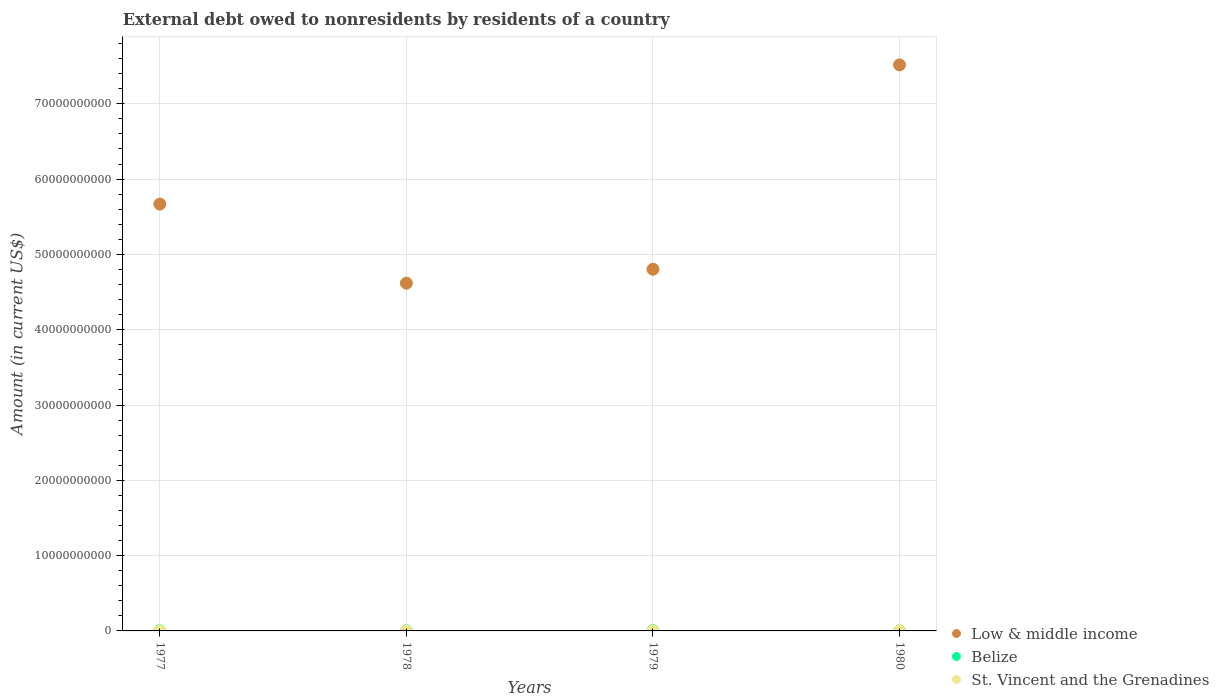Is the number of dotlines equal to the number of legend labels?
Give a very brief answer. No. What is the external debt owed by residents in Belize in 1977?
Provide a short and direct response. 1.13e+07. Across all years, what is the maximum external debt owed by residents in Belize?
Keep it short and to the point. 3.81e+07. Across all years, what is the minimum external debt owed by residents in Low & middle income?
Offer a terse response. 4.62e+1. What is the total external debt owed by residents in Belize in the graph?
Your response must be concise. 6.21e+07. What is the difference between the external debt owed by residents in Low & middle income in 1977 and that in 1978?
Your response must be concise. 1.05e+1. What is the difference between the external debt owed by residents in Belize in 1980 and the external debt owed by residents in Low & middle income in 1977?
Keep it short and to the point. -5.67e+1. What is the average external debt owed by residents in St. Vincent and the Grenadines per year?
Your response must be concise. 1.63e+06. In the year 1979, what is the difference between the external debt owed by residents in St. Vincent and the Grenadines and external debt owed by residents in Belize?
Offer a very short reply. -3.68e+07. What is the ratio of the external debt owed by residents in Low & middle income in 1977 to that in 1979?
Your answer should be very brief. 1.18. Is the external debt owed by residents in Low & middle income in 1977 less than that in 1979?
Provide a short and direct response. No. Is the difference between the external debt owed by residents in St. Vincent and the Grenadines in 1978 and 1979 greater than the difference between the external debt owed by residents in Belize in 1978 and 1979?
Keep it short and to the point. Yes. What is the difference between the highest and the second highest external debt owed by residents in Low & middle income?
Ensure brevity in your answer.  1.85e+1. What is the difference between the highest and the lowest external debt owed by residents in St. Vincent and the Grenadines?
Provide a short and direct response. 2.54e+06. In how many years, is the external debt owed by residents in Low & middle income greater than the average external debt owed by residents in Low & middle income taken over all years?
Your response must be concise. 2. Is the sum of the external debt owed by residents in Low & middle income in 1978 and 1979 greater than the maximum external debt owed by residents in Belize across all years?
Give a very brief answer. Yes. Is it the case that in every year, the sum of the external debt owed by residents in St. Vincent and the Grenadines and external debt owed by residents in Low & middle income  is greater than the external debt owed by residents in Belize?
Provide a short and direct response. Yes. Does the external debt owed by residents in St. Vincent and the Grenadines monotonically increase over the years?
Provide a succinct answer. Yes. Is the external debt owed by residents in Low & middle income strictly less than the external debt owed by residents in Belize over the years?
Your answer should be compact. No. How many dotlines are there?
Your response must be concise. 3. Are the values on the major ticks of Y-axis written in scientific E-notation?
Your response must be concise. No. Does the graph contain grids?
Your answer should be compact. Yes. Where does the legend appear in the graph?
Offer a terse response. Bottom right. How are the legend labels stacked?
Make the answer very short. Vertical. What is the title of the graph?
Give a very brief answer. External debt owed to nonresidents by residents of a country. Does "Afghanistan" appear as one of the legend labels in the graph?
Your answer should be very brief. No. What is the label or title of the X-axis?
Your answer should be compact. Years. What is the label or title of the Y-axis?
Ensure brevity in your answer.  Amount (in current US$). What is the Amount (in current US$) of Low & middle income in 1977?
Provide a short and direct response. 5.67e+1. What is the Amount (in current US$) in Belize in 1977?
Provide a short and direct response. 1.13e+07. What is the Amount (in current US$) of St. Vincent and the Grenadines in 1977?
Make the answer very short. 8.55e+05. What is the Amount (in current US$) of Low & middle income in 1978?
Make the answer very short. 4.62e+1. What is the Amount (in current US$) of Belize in 1978?
Provide a short and direct response. 1.27e+07. What is the Amount (in current US$) of St. Vincent and the Grenadines in 1978?
Provide a short and direct response. 9.76e+05. What is the Amount (in current US$) in Low & middle income in 1979?
Offer a very short reply. 4.80e+1. What is the Amount (in current US$) of Belize in 1979?
Your answer should be very brief. 3.81e+07. What is the Amount (in current US$) in St. Vincent and the Grenadines in 1979?
Ensure brevity in your answer.  1.28e+06. What is the Amount (in current US$) of Low & middle income in 1980?
Give a very brief answer. 7.52e+1. What is the Amount (in current US$) in St. Vincent and the Grenadines in 1980?
Ensure brevity in your answer.  3.39e+06. Across all years, what is the maximum Amount (in current US$) of Low & middle income?
Your answer should be compact. 7.52e+1. Across all years, what is the maximum Amount (in current US$) in Belize?
Keep it short and to the point. 3.81e+07. Across all years, what is the maximum Amount (in current US$) in St. Vincent and the Grenadines?
Keep it short and to the point. 3.39e+06. Across all years, what is the minimum Amount (in current US$) in Low & middle income?
Provide a short and direct response. 4.62e+1. Across all years, what is the minimum Amount (in current US$) in St. Vincent and the Grenadines?
Your response must be concise. 8.55e+05. What is the total Amount (in current US$) in Low & middle income in the graph?
Provide a succinct answer. 2.26e+11. What is the total Amount (in current US$) in Belize in the graph?
Ensure brevity in your answer.  6.21e+07. What is the total Amount (in current US$) in St. Vincent and the Grenadines in the graph?
Make the answer very short. 6.50e+06. What is the difference between the Amount (in current US$) in Low & middle income in 1977 and that in 1978?
Make the answer very short. 1.05e+1. What is the difference between the Amount (in current US$) of Belize in 1977 and that in 1978?
Give a very brief answer. -1.41e+06. What is the difference between the Amount (in current US$) of St. Vincent and the Grenadines in 1977 and that in 1978?
Your response must be concise. -1.21e+05. What is the difference between the Amount (in current US$) in Low & middle income in 1977 and that in 1979?
Make the answer very short. 8.65e+09. What is the difference between the Amount (in current US$) of Belize in 1977 and that in 1979?
Give a very brief answer. -2.67e+07. What is the difference between the Amount (in current US$) in St. Vincent and the Grenadines in 1977 and that in 1979?
Offer a terse response. -4.24e+05. What is the difference between the Amount (in current US$) of Low & middle income in 1977 and that in 1980?
Ensure brevity in your answer.  -1.85e+1. What is the difference between the Amount (in current US$) in St. Vincent and the Grenadines in 1977 and that in 1980?
Your answer should be compact. -2.54e+06. What is the difference between the Amount (in current US$) in Low & middle income in 1978 and that in 1979?
Ensure brevity in your answer.  -1.85e+09. What is the difference between the Amount (in current US$) of Belize in 1978 and that in 1979?
Make the answer very short. -2.53e+07. What is the difference between the Amount (in current US$) of St. Vincent and the Grenadines in 1978 and that in 1979?
Your answer should be very brief. -3.03e+05. What is the difference between the Amount (in current US$) of Low & middle income in 1978 and that in 1980?
Your response must be concise. -2.90e+1. What is the difference between the Amount (in current US$) of St. Vincent and the Grenadines in 1978 and that in 1980?
Give a very brief answer. -2.42e+06. What is the difference between the Amount (in current US$) of Low & middle income in 1979 and that in 1980?
Your answer should be compact. -2.71e+1. What is the difference between the Amount (in current US$) of St. Vincent and the Grenadines in 1979 and that in 1980?
Ensure brevity in your answer.  -2.11e+06. What is the difference between the Amount (in current US$) of Low & middle income in 1977 and the Amount (in current US$) of Belize in 1978?
Ensure brevity in your answer.  5.67e+1. What is the difference between the Amount (in current US$) in Low & middle income in 1977 and the Amount (in current US$) in St. Vincent and the Grenadines in 1978?
Ensure brevity in your answer.  5.67e+1. What is the difference between the Amount (in current US$) of Belize in 1977 and the Amount (in current US$) of St. Vincent and the Grenadines in 1978?
Offer a very short reply. 1.03e+07. What is the difference between the Amount (in current US$) in Low & middle income in 1977 and the Amount (in current US$) in Belize in 1979?
Make the answer very short. 5.66e+1. What is the difference between the Amount (in current US$) in Low & middle income in 1977 and the Amount (in current US$) in St. Vincent and the Grenadines in 1979?
Ensure brevity in your answer.  5.67e+1. What is the difference between the Amount (in current US$) of Belize in 1977 and the Amount (in current US$) of St. Vincent and the Grenadines in 1979?
Ensure brevity in your answer.  1.00e+07. What is the difference between the Amount (in current US$) of Low & middle income in 1977 and the Amount (in current US$) of St. Vincent and the Grenadines in 1980?
Offer a very short reply. 5.67e+1. What is the difference between the Amount (in current US$) of Belize in 1977 and the Amount (in current US$) of St. Vincent and the Grenadines in 1980?
Provide a succinct answer. 7.92e+06. What is the difference between the Amount (in current US$) in Low & middle income in 1978 and the Amount (in current US$) in Belize in 1979?
Provide a succinct answer. 4.61e+1. What is the difference between the Amount (in current US$) of Low & middle income in 1978 and the Amount (in current US$) of St. Vincent and the Grenadines in 1979?
Keep it short and to the point. 4.62e+1. What is the difference between the Amount (in current US$) in Belize in 1978 and the Amount (in current US$) in St. Vincent and the Grenadines in 1979?
Keep it short and to the point. 1.14e+07. What is the difference between the Amount (in current US$) in Low & middle income in 1978 and the Amount (in current US$) in St. Vincent and the Grenadines in 1980?
Ensure brevity in your answer.  4.62e+1. What is the difference between the Amount (in current US$) of Belize in 1978 and the Amount (in current US$) of St. Vincent and the Grenadines in 1980?
Your response must be concise. 9.33e+06. What is the difference between the Amount (in current US$) of Low & middle income in 1979 and the Amount (in current US$) of St. Vincent and the Grenadines in 1980?
Give a very brief answer. 4.80e+1. What is the difference between the Amount (in current US$) in Belize in 1979 and the Amount (in current US$) in St. Vincent and the Grenadines in 1980?
Your answer should be compact. 3.47e+07. What is the average Amount (in current US$) of Low & middle income per year?
Give a very brief answer. 5.65e+1. What is the average Amount (in current US$) in Belize per year?
Offer a very short reply. 1.55e+07. What is the average Amount (in current US$) in St. Vincent and the Grenadines per year?
Provide a short and direct response. 1.63e+06. In the year 1977, what is the difference between the Amount (in current US$) in Low & middle income and Amount (in current US$) in Belize?
Provide a short and direct response. 5.67e+1. In the year 1977, what is the difference between the Amount (in current US$) of Low & middle income and Amount (in current US$) of St. Vincent and the Grenadines?
Offer a very short reply. 5.67e+1. In the year 1977, what is the difference between the Amount (in current US$) in Belize and Amount (in current US$) in St. Vincent and the Grenadines?
Offer a very short reply. 1.05e+07. In the year 1978, what is the difference between the Amount (in current US$) in Low & middle income and Amount (in current US$) in Belize?
Give a very brief answer. 4.62e+1. In the year 1978, what is the difference between the Amount (in current US$) in Low & middle income and Amount (in current US$) in St. Vincent and the Grenadines?
Keep it short and to the point. 4.62e+1. In the year 1978, what is the difference between the Amount (in current US$) in Belize and Amount (in current US$) in St. Vincent and the Grenadines?
Give a very brief answer. 1.17e+07. In the year 1979, what is the difference between the Amount (in current US$) in Low & middle income and Amount (in current US$) in Belize?
Offer a terse response. 4.80e+1. In the year 1979, what is the difference between the Amount (in current US$) in Low & middle income and Amount (in current US$) in St. Vincent and the Grenadines?
Ensure brevity in your answer.  4.80e+1. In the year 1979, what is the difference between the Amount (in current US$) in Belize and Amount (in current US$) in St. Vincent and the Grenadines?
Offer a terse response. 3.68e+07. In the year 1980, what is the difference between the Amount (in current US$) in Low & middle income and Amount (in current US$) in St. Vincent and the Grenadines?
Offer a very short reply. 7.52e+1. What is the ratio of the Amount (in current US$) in Low & middle income in 1977 to that in 1978?
Provide a succinct answer. 1.23. What is the ratio of the Amount (in current US$) in Belize in 1977 to that in 1978?
Provide a short and direct response. 0.89. What is the ratio of the Amount (in current US$) in St. Vincent and the Grenadines in 1977 to that in 1978?
Your answer should be very brief. 0.88. What is the ratio of the Amount (in current US$) of Low & middle income in 1977 to that in 1979?
Provide a succinct answer. 1.18. What is the ratio of the Amount (in current US$) in Belize in 1977 to that in 1979?
Provide a succinct answer. 0.3. What is the ratio of the Amount (in current US$) in St. Vincent and the Grenadines in 1977 to that in 1979?
Ensure brevity in your answer.  0.67. What is the ratio of the Amount (in current US$) in Low & middle income in 1977 to that in 1980?
Your answer should be very brief. 0.75. What is the ratio of the Amount (in current US$) in St. Vincent and the Grenadines in 1977 to that in 1980?
Your response must be concise. 0.25. What is the ratio of the Amount (in current US$) in Low & middle income in 1978 to that in 1979?
Provide a short and direct response. 0.96. What is the ratio of the Amount (in current US$) in Belize in 1978 to that in 1979?
Provide a short and direct response. 0.33. What is the ratio of the Amount (in current US$) of St. Vincent and the Grenadines in 1978 to that in 1979?
Give a very brief answer. 0.76. What is the ratio of the Amount (in current US$) in Low & middle income in 1978 to that in 1980?
Give a very brief answer. 0.61. What is the ratio of the Amount (in current US$) of St. Vincent and the Grenadines in 1978 to that in 1980?
Offer a very short reply. 0.29. What is the ratio of the Amount (in current US$) in Low & middle income in 1979 to that in 1980?
Keep it short and to the point. 0.64. What is the ratio of the Amount (in current US$) of St. Vincent and the Grenadines in 1979 to that in 1980?
Your response must be concise. 0.38. What is the difference between the highest and the second highest Amount (in current US$) of Low & middle income?
Provide a succinct answer. 1.85e+1. What is the difference between the highest and the second highest Amount (in current US$) in Belize?
Offer a very short reply. 2.53e+07. What is the difference between the highest and the second highest Amount (in current US$) of St. Vincent and the Grenadines?
Keep it short and to the point. 2.11e+06. What is the difference between the highest and the lowest Amount (in current US$) of Low & middle income?
Provide a short and direct response. 2.90e+1. What is the difference between the highest and the lowest Amount (in current US$) in Belize?
Your answer should be compact. 3.81e+07. What is the difference between the highest and the lowest Amount (in current US$) in St. Vincent and the Grenadines?
Your answer should be very brief. 2.54e+06. 